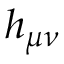<formula> <loc_0><loc_0><loc_500><loc_500>h _ { \mu \nu }</formula> 